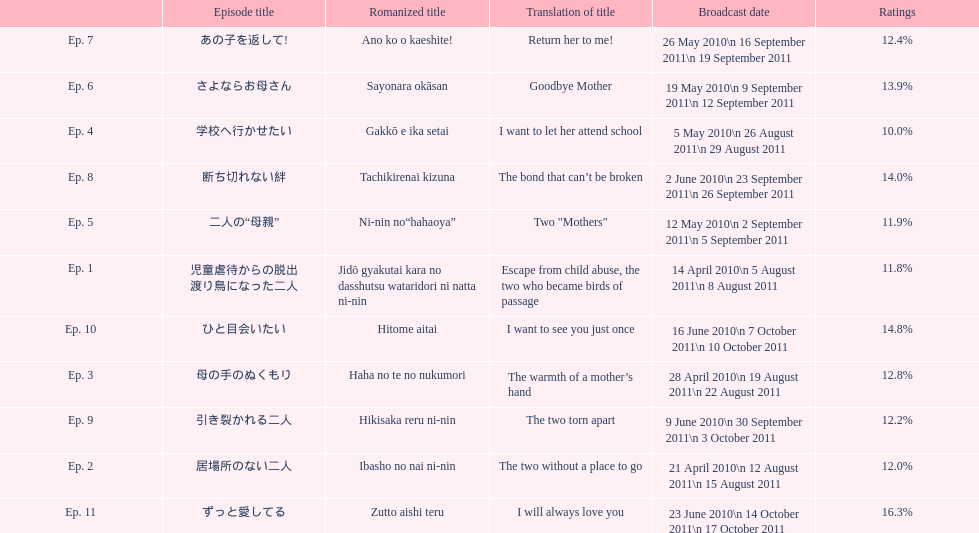How many episode are not over 14%? 8. 